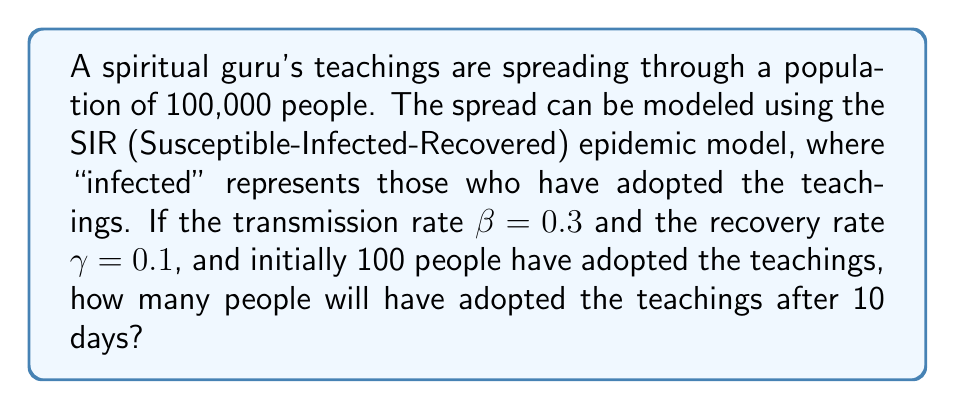What is the answer to this math problem? To solve this problem, we'll use the SIR model equations and numerical methods to approximate the solution:

1. The SIR model is described by the following differential equations:

   $$\frac{dS}{dt} = -\beta SI$$
   $$\frac{dI}{dt} = \beta SI - \gamma I$$
   $$\frac{dR}{dt} = \gamma I$$

   Where S is the number of susceptible individuals, I is the number of infected (or in this case, those who have adopted the teachings), and R is the number of recovered (or those who have abandoned the teachings).

2. Given:
   - Total population N = 100,000
   - Initial infected I₀ = 100
   - β = 0.3
   - γ = 0.1
   - Time t = 10 days

3. We'll use the Euler method to approximate the solution. Let's use a step size of h = 0.1 days.

4. Initialize:
   S₀ = N - I₀ = 99,900
   R₀ = 0
   
5. For each step i (0 ≤ i < 100):
   $$S_{i+1} = S_i - h\beta S_i I_i / N$$
   $$I_{i+1} = I_i + h(\beta S_i I_i / N - \gamma I_i)$$
   $$R_{i+1} = R_i + h\gamma I_i$$

6. Implement this in a programming language or spreadsheet to calculate the values after 10 days (100 steps).

7. After calculation, we find that approximately 1,823 people will have adopted the teachings after 10 days.

This solution demonstrates how the guru's spiritual teachings spread through the population, similar to how an epidemic might propagate. The transmission rate β represents the effectiveness of the guru's message and the recovery rate γ represents the rate at which people lose interest or abandon the teachings.
Answer: Approximately 1,823 people will have adopted the guru's teachings after 10 days. 